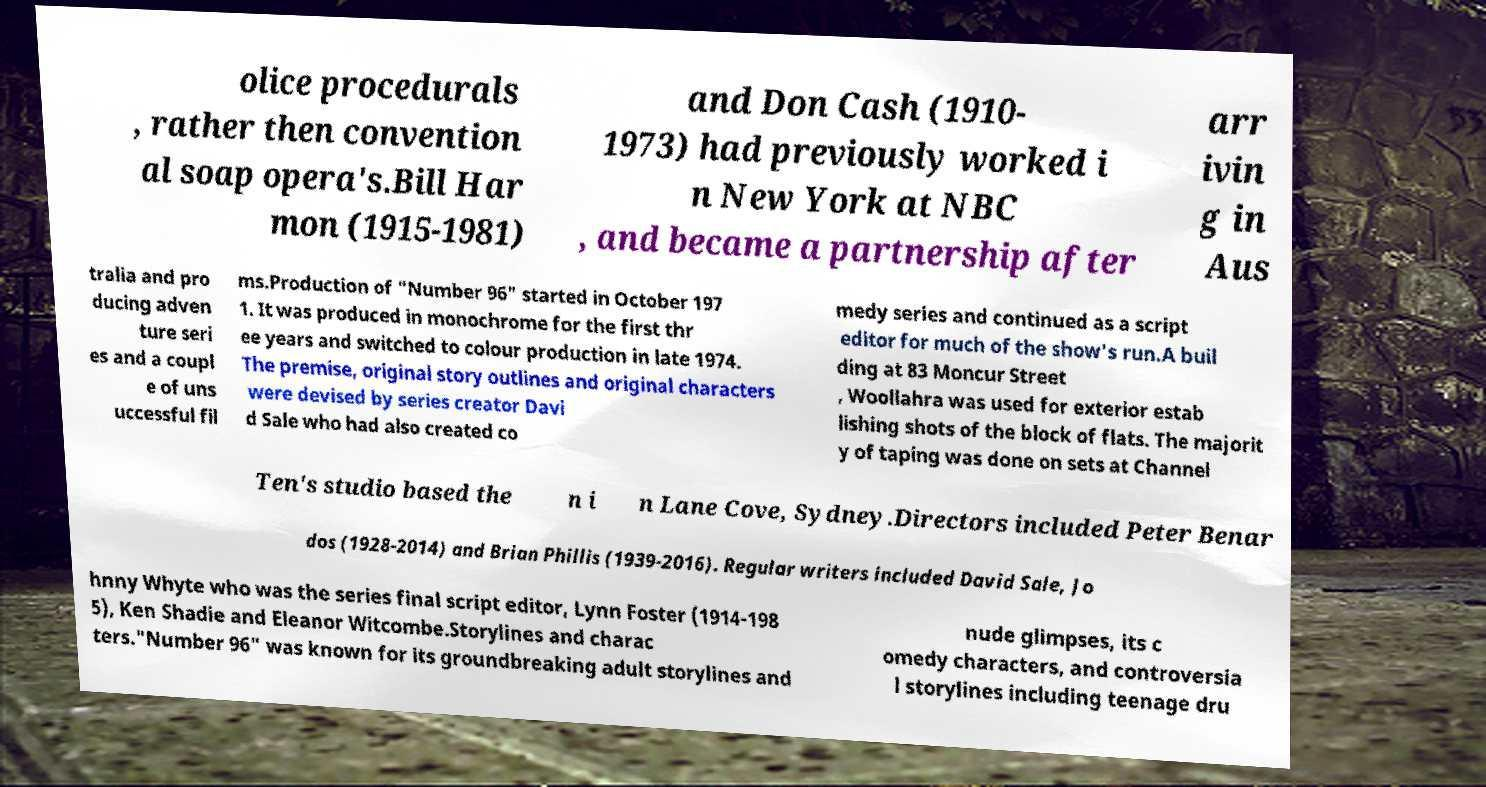Can you accurately transcribe the text from the provided image for me? olice procedurals , rather then convention al soap opera's.Bill Har mon (1915-1981) and Don Cash (1910- 1973) had previously worked i n New York at NBC , and became a partnership after arr ivin g in Aus tralia and pro ducing adven ture seri es and a coupl e of uns uccessful fil ms.Production of "Number 96" started in October 197 1. It was produced in monochrome for the first thr ee years and switched to colour production in late 1974. The premise, original story outlines and original characters were devised by series creator Davi d Sale who had also created co medy series and continued as a script editor for much of the show's run.A buil ding at 83 Moncur Street , Woollahra was used for exterior estab lishing shots of the block of flats. The majorit y of taping was done on sets at Channel Ten's studio based the n i n Lane Cove, Sydney.Directors included Peter Benar dos (1928-2014) and Brian Phillis (1939-2016). Regular writers included David Sale, Jo hnny Whyte who was the series final script editor, Lynn Foster (1914-198 5), Ken Shadie and Eleanor Witcombe.Storylines and charac ters."Number 96" was known for its groundbreaking adult storylines and nude glimpses, its c omedy characters, and controversia l storylines including teenage dru 